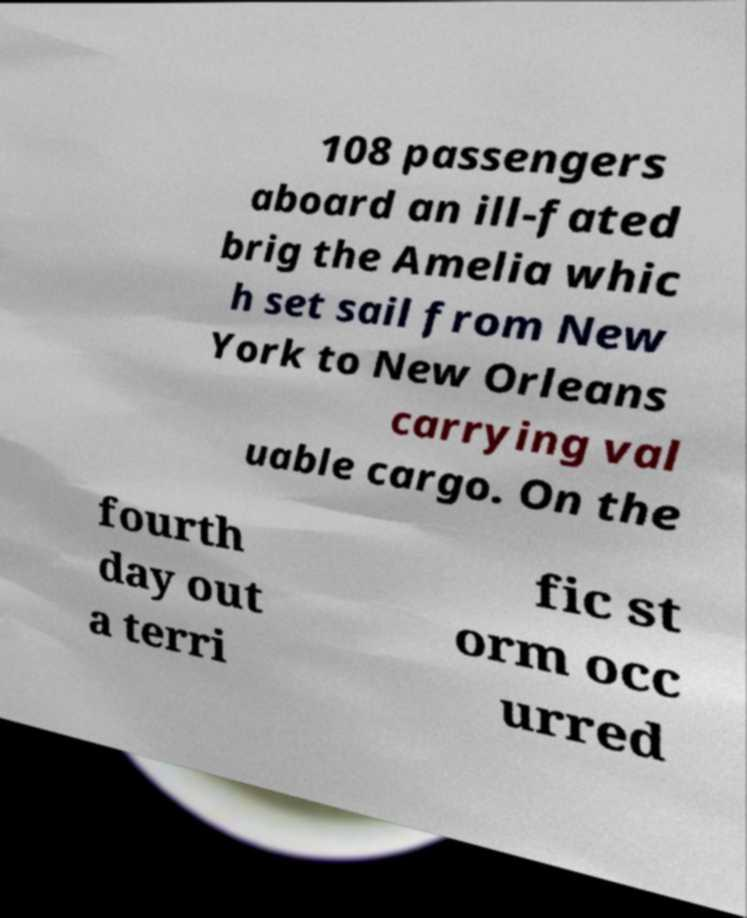Could you extract and type out the text from this image? 108 passengers aboard an ill-fated brig the Amelia whic h set sail from New York to New Orleans carrying val uable cargo. On the fourth day out a terri fic st orm occ urred 